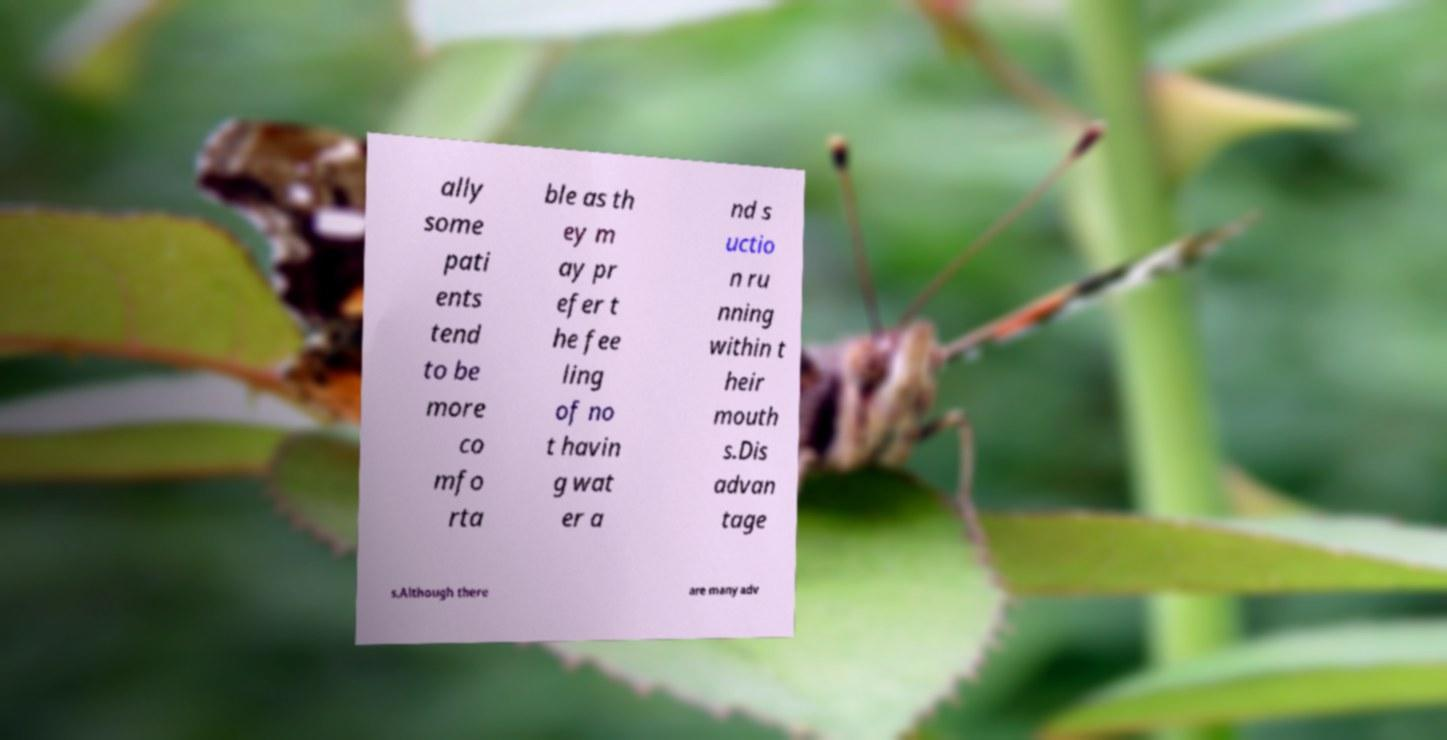What messages or text are displayed in this image? I need them in a readable, typed format. ally some pati ents tend to be more co mfo rta ble as th ey m ay pr efer t he fee ling of no t havin g wat er a nd s uctio n ru nning within t heir mouth s.Dis advan tage s.Although there are many adv 